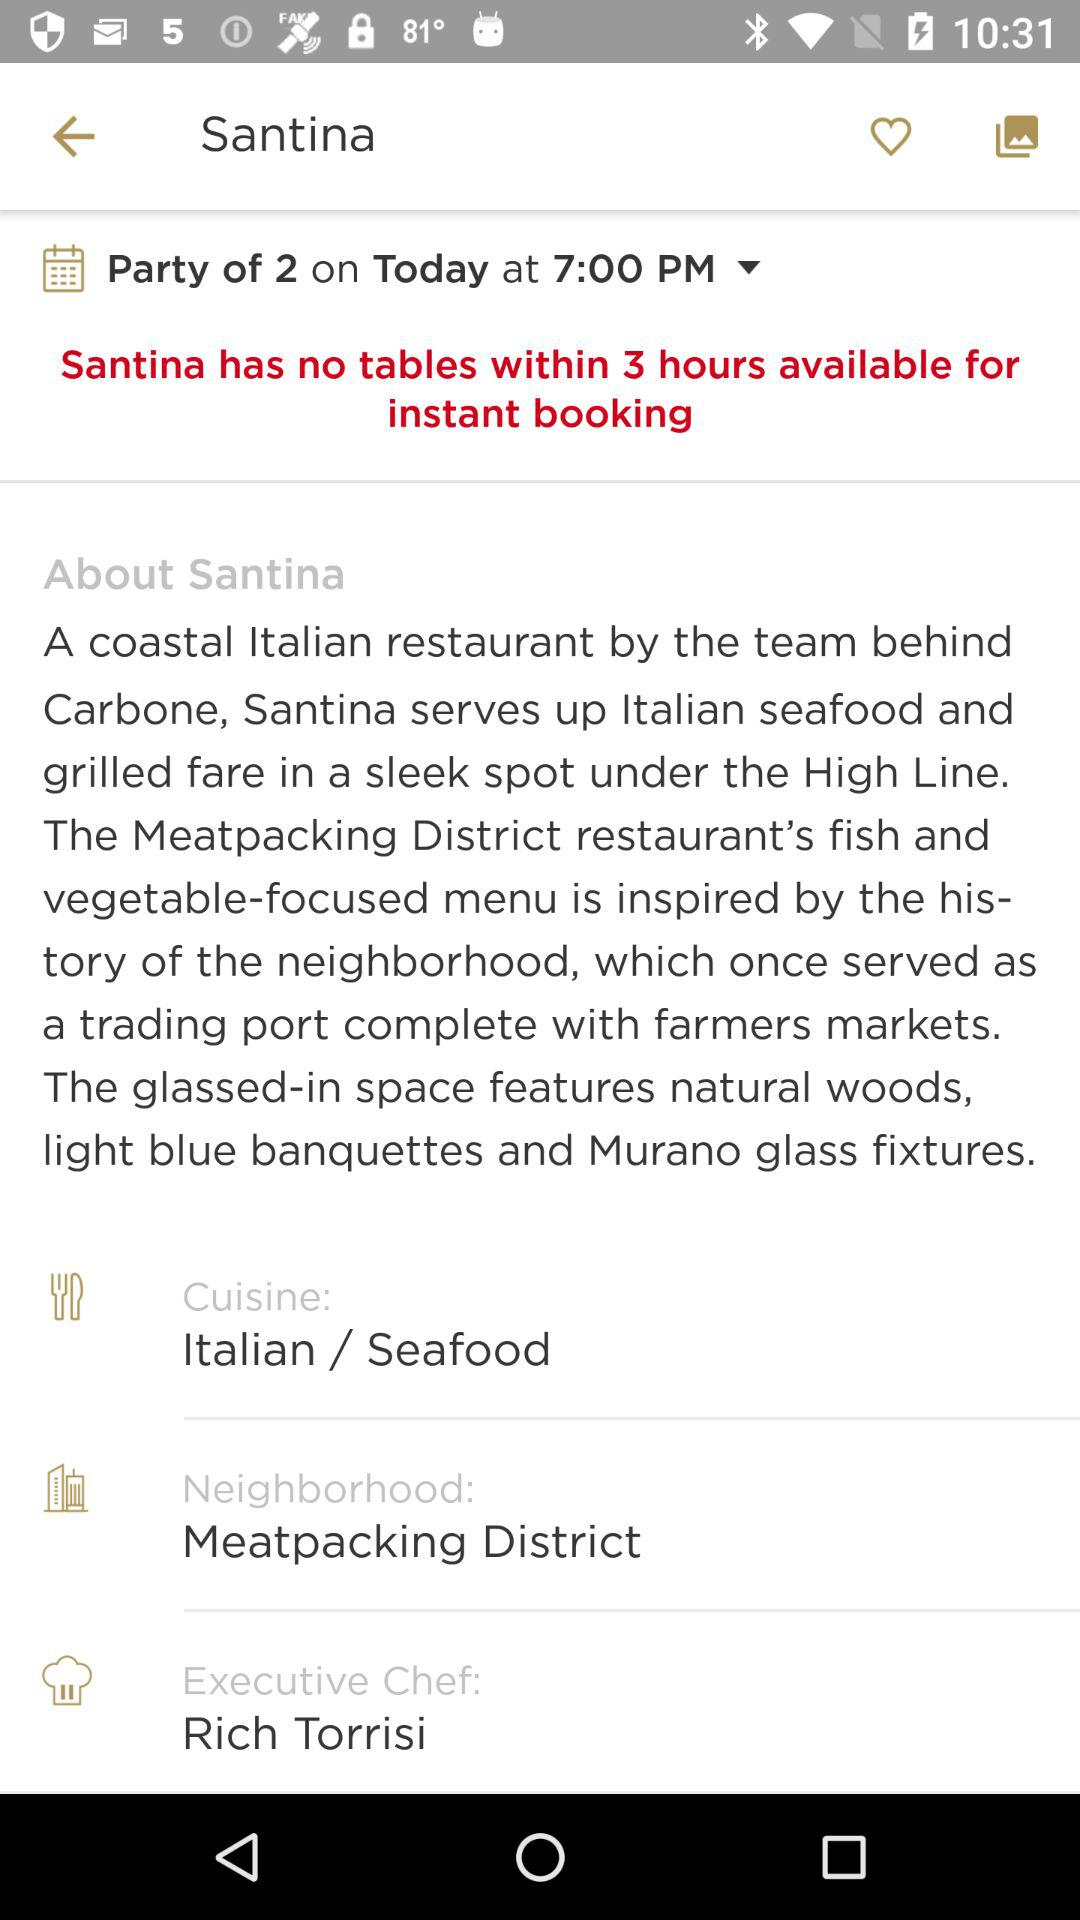What type of cuisine is served in "Santina"? The type of cuisine that is served in "Santina" is Italian and seafood. 